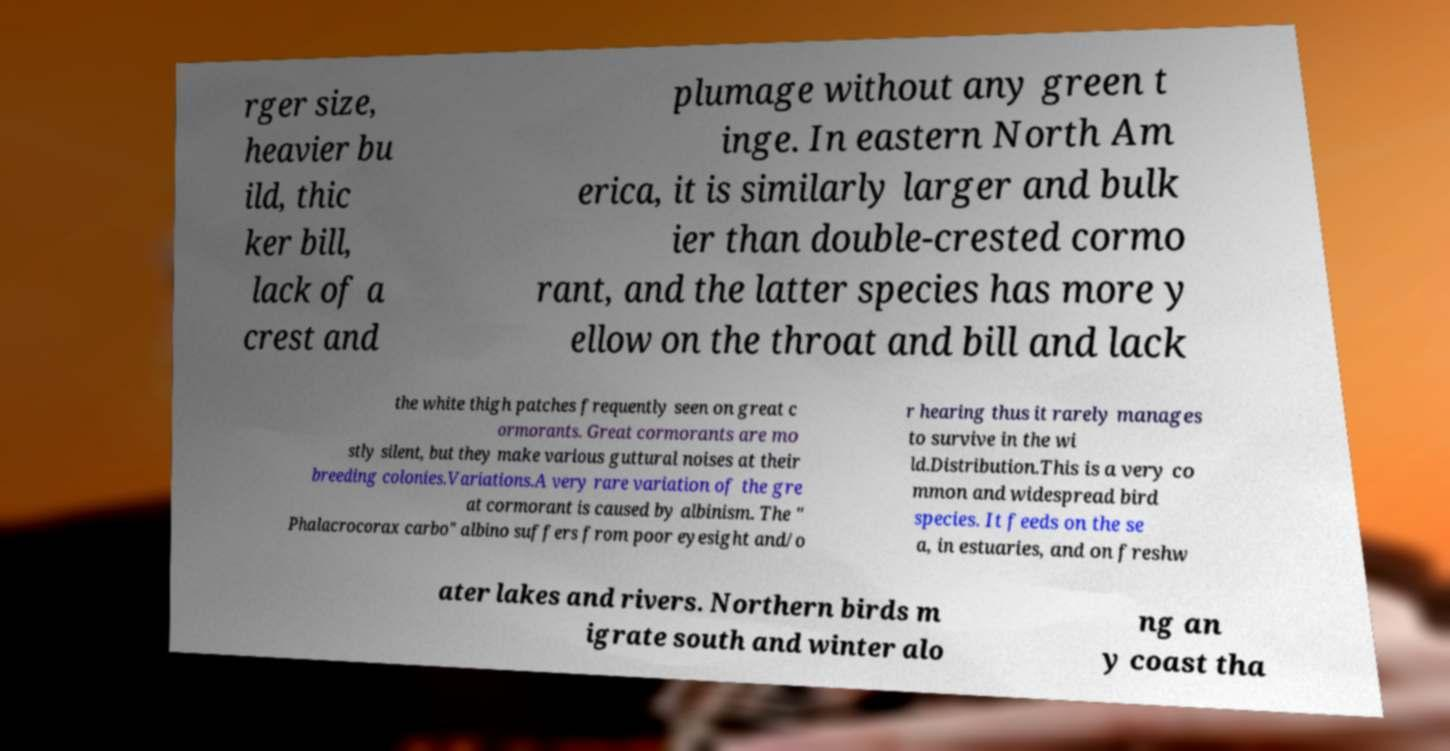Can you read and provide the text displayed in the image?This photo seems to have some interesting text. Can you extract and type it out for me? rger size, heavier bu ild, thic ker bill, lack of a crest and plumage without any green t inge. In eastern North Am erica, it is similarly larger and bulk ier than double-crested cormo rant, and the latter species has more y ellow on the throat and bill and lack the white thigh patches frequently seen on great c ormorants. Great cormorants are mo stly silent, but they make various guttural noises at their breeding colonies.Variations.A very rare variation of the gre at cormorant is caused by albinism. The " Phalacrocorax carbo" albino suffers from poor eyesight and/o r hearing thus it rarely manages to survive in the wi ld.Distribution.This is a very co mmon and widespread bird species. It feeds on the se a, in estuaries, and on freshw ater lakes and rivers. Northern birds m igrate south and winter alo ng an y coast tha 